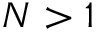<formula> <loc_0><loc_0><loc_500><loc_500>N > 1</formula> 